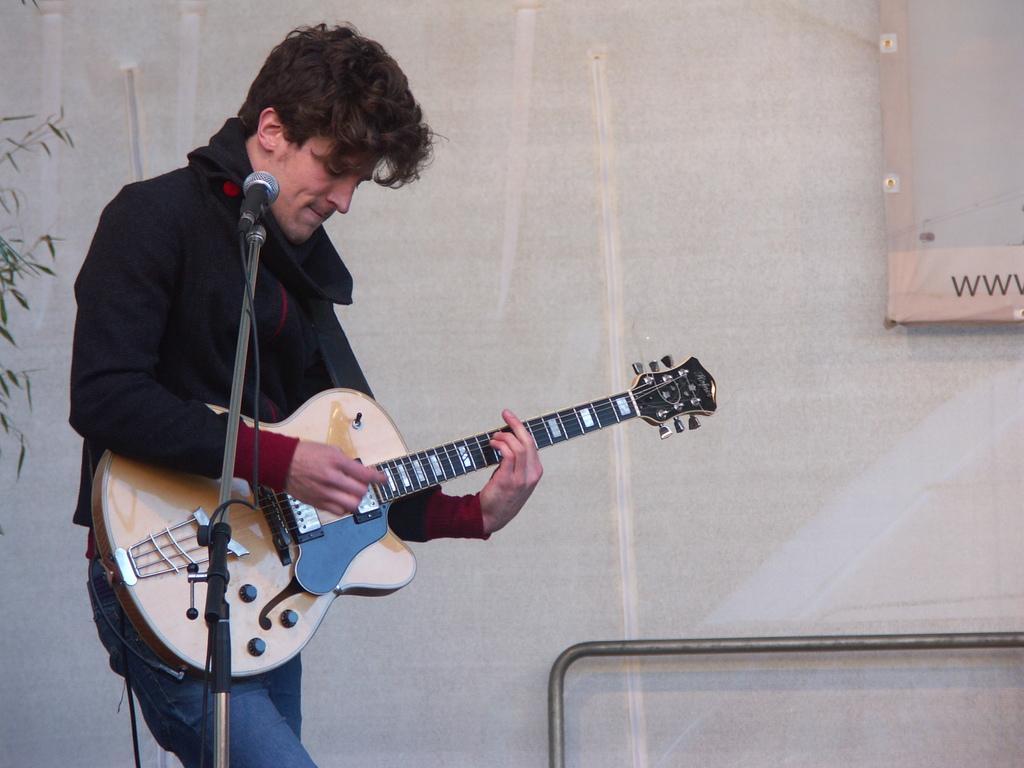Please provide a concise description of this image. In the image there is a stand with a mic and wire to it. There is a man standing and holding the guitar. Behind him there is a rod. On the left side of the image there are leaves. 